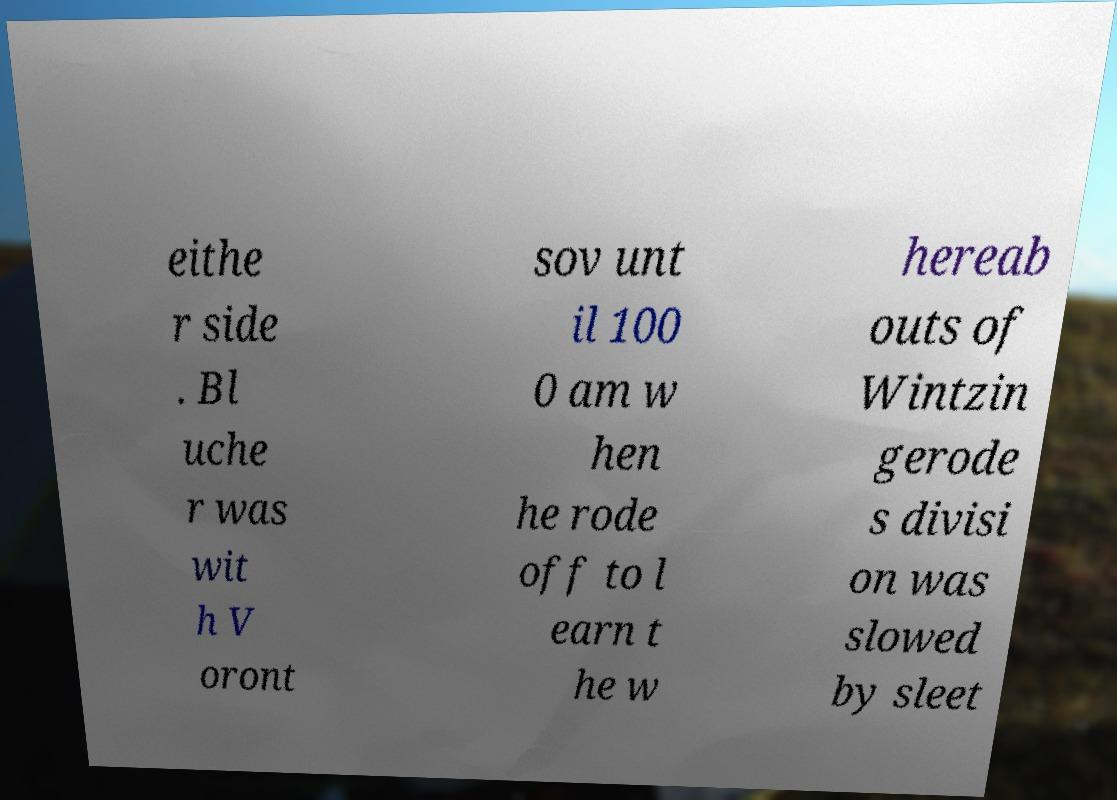Can you read and provide the text displayed in the image?This photo seems to have some interesting text. Can you extract and type it out for me? eithe r side . Bl uche r was wit h V oront sov unt il 100 0 am w hen he rode off to l earn t he w hereab outs of Wintzin gerode s divisi on was slowed by sleet 